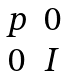Convert formula to latex. <formula><loc_0><loc_0><loc_500><loc_500>\begin{matrix} p & 0 \\ 0 & I \end{matrix}</formula> 